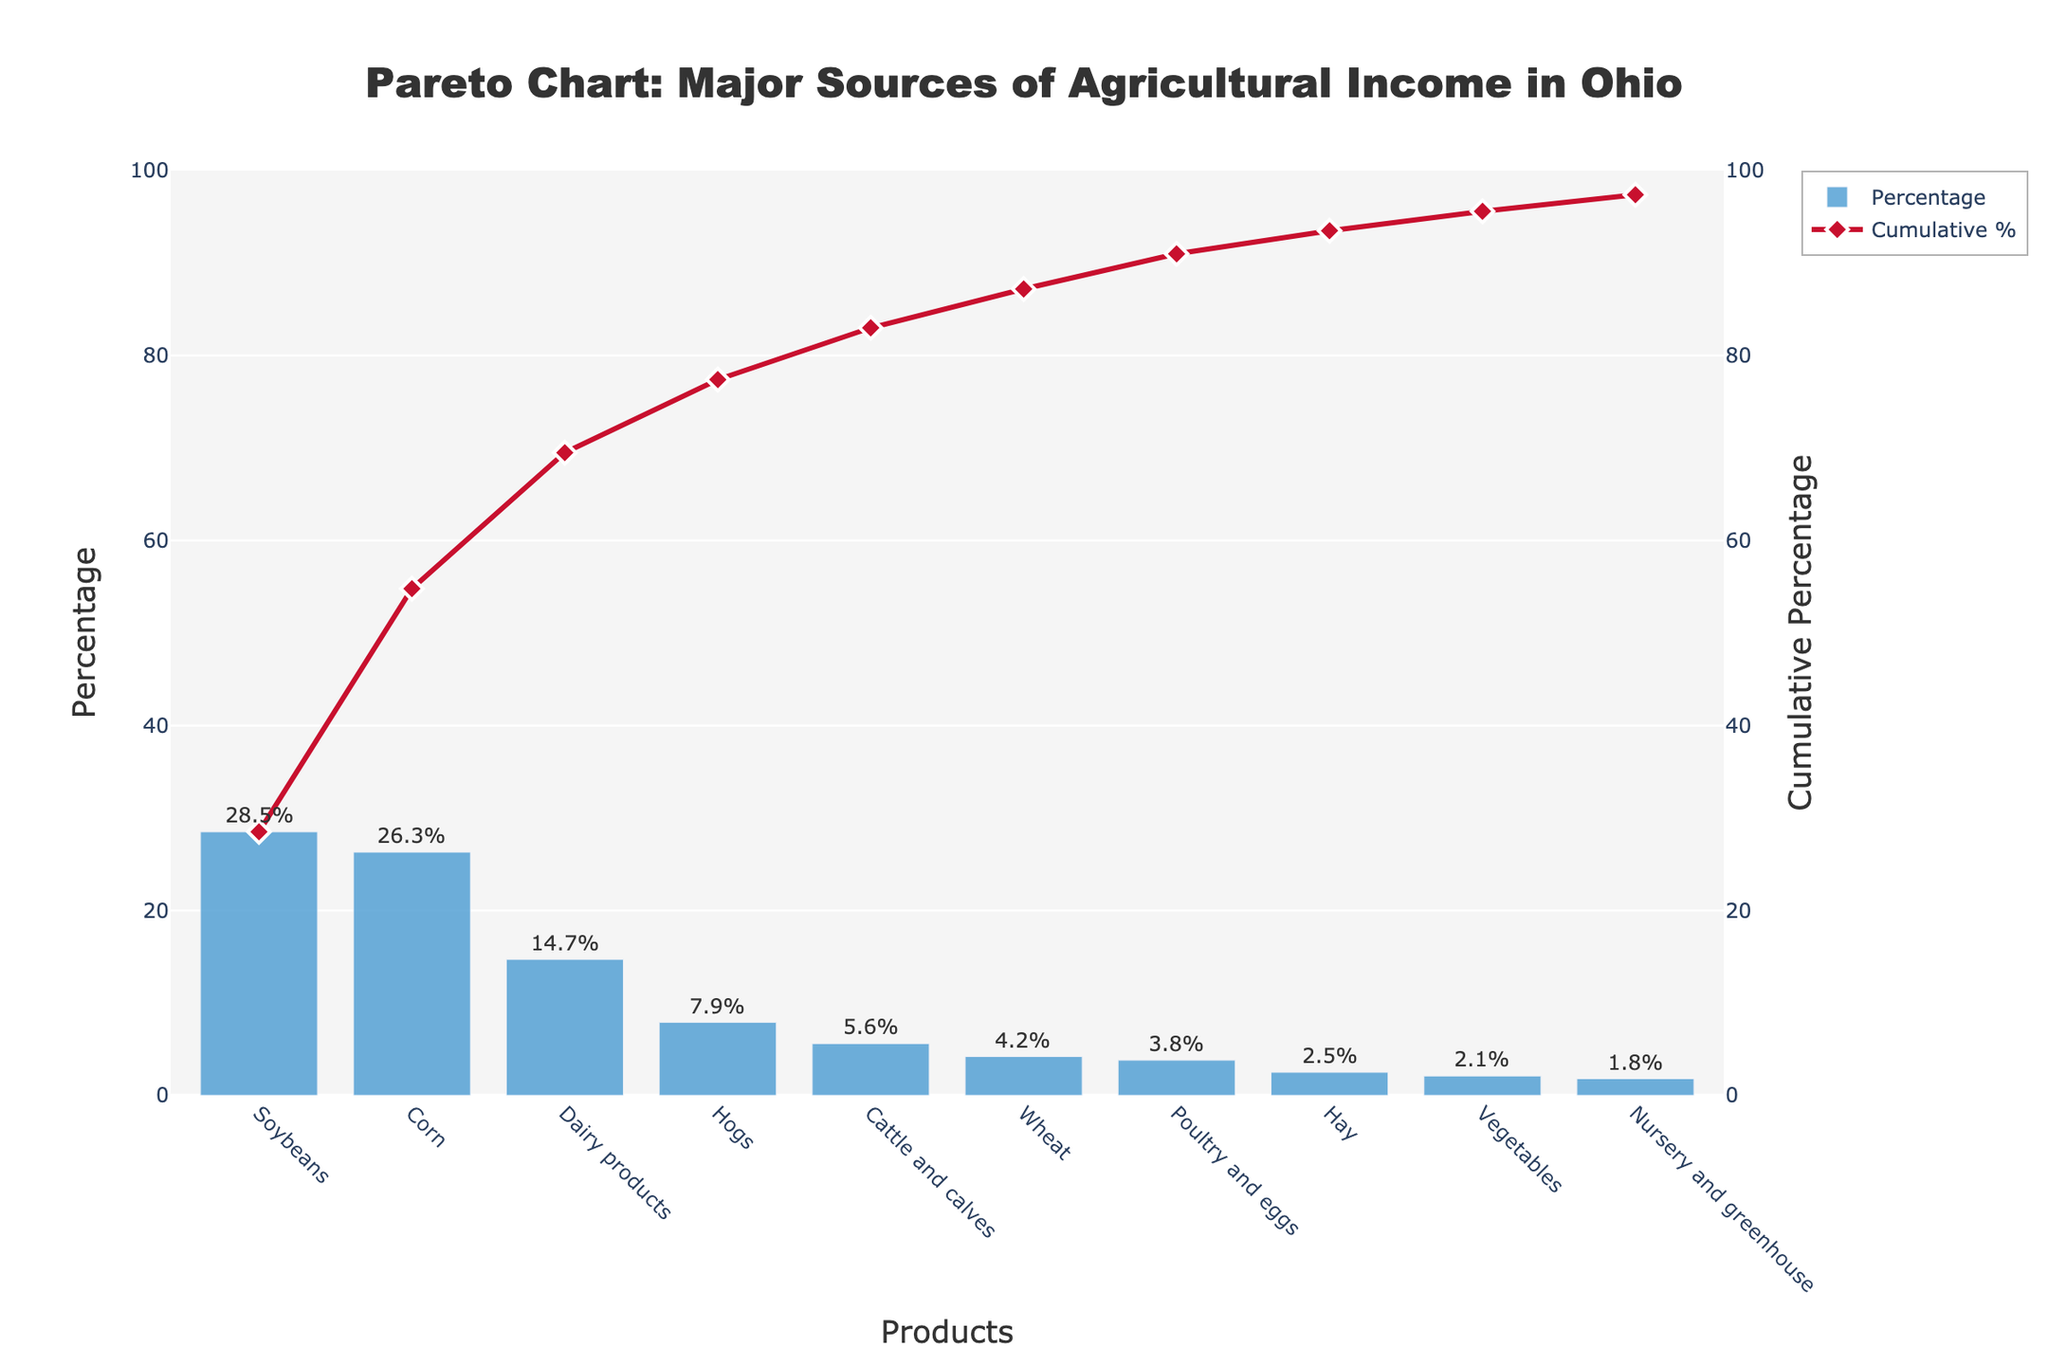What is the title of the chart? The title of the chart is displayed at the top and it reads "Pareto Chart: Major Sources of Agricultural Income in Ohio".
Answer: Pareto Chart: Major Sources of Agricultural Income in Ohio Which product has the highest percentage contribution? The first bar in the chart represents the product with the highest percentage contribution. It shows Soybeans having a contribution of 28.5%.
Answer: Soybeans How much percentage do Dairy products contribute? The bar labeled "Dairy products" shows the percentage contribution. It indicates a contribution of 14.7%.
Answer: 14.7% What is the cumulative percentage for the first three products? To find the cumulative percentage, sum the contributions of the first three products, which are Soybeans (28.5%), Corn (26.3%), and Dairy products (14.7%). The sum is 28.5 + 26.3 + 14.7 = 69.5%.
Answer: 69.5% Which product has the least percentage contribution? The last bar in the chart represents the product with the least percentage contribution. It shows Nursery and greenhouse with a percentage of 1.8%.
Answer: Nursery and greenhouse How many products have a contribution higher than 10%? Count the bars which have a percentage value higher than 10%. These are Soybeans (28.5%), Corn (26.3%), and Dairy products (14.7%), making a total of three products.
Answer: 3 Are there more products with contributions above or below 5%? Count the number of products above 5% (Soybeans, Corn, Dairy products, Hogs, Cattle and calves - 5 in total) and below 5% (Wheat, Poultry and eggs, Hay, Vegetables, Nursery and greenhouse - 5 in total). Both categories have an equal number of products.
Answer: Equal What is the combined percentage of Hogs and Cattle and calves? Add the percentages of Hogs (7.9%) and Cattle and calves (5.6%) to find the combined percentage. 7.9 + 5.6 = 13.5%.
Answer: 13.5% Does the cumulative percentage ever exceed 50%? By looking at the cumulative line plot, identify if it crosses the 50% mark. The first three products (Soybeans, Corn, Dairy products) collectively reach 69.5%, thus the cumulative percentage exceeds 50%.
Answer: Yes How does the percentage contribution of Corn compare to that of Hay? Compare the values of the bars labeled “Corn” (26.3%) and “Hay” (2.5%). The percentage contribution of Corn is significantly higher than that of Hay.
Answer: Corn is higher 